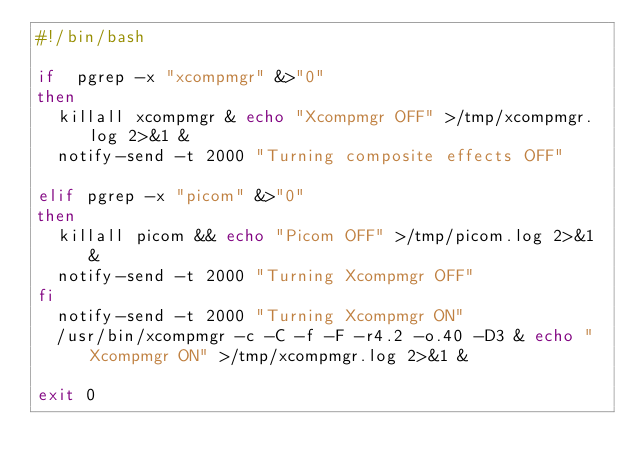Convert code to text. <code><loc_0><loc_0><loc_500><loc_500><_Bash_>#!/bin/bash

if	pgrep -x "xcompmgr" &>"0"
then
	killall xcompmgr & echo "Xcompmgr OFF" >/tmp/xcompmgr.log 2>&1 &
	notify-send -t 2000 "Turning composite effects OFF" 
	
elif pgrep -x "picom" &>"0"
then 
	killall picom && echo "Picom OFF" >/tmp/picom.log 2>&1 &
	notify-send -t 2000 "Turning Xcompmgr OFF" 			
fi	
	notify-send -t 2000 "Turning Xcompmgr ON"
	/usr/bin/xcompmgr -c -C -f -F -r4.2 -o.40 -D3 & echo "Xcompmgr ON" >/tmp/xcompmgr.log 2>&1 &

exit 0
</code> 